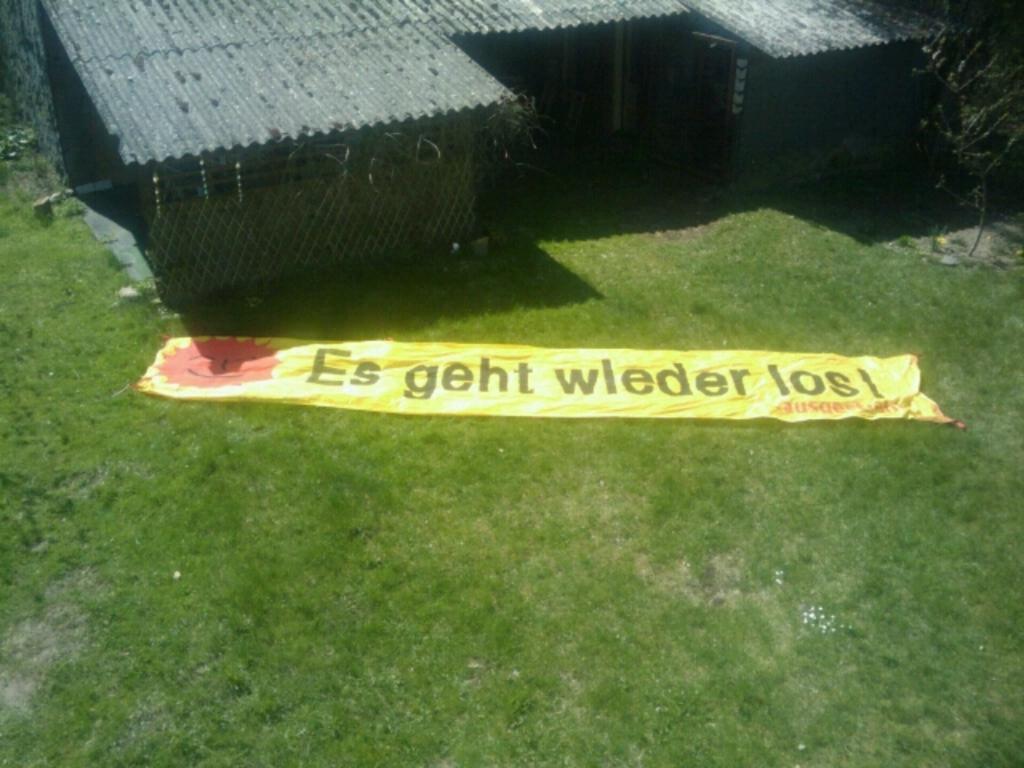Please provide a concise description of this image. We can see banner on the grass and we can see shed and plant. 